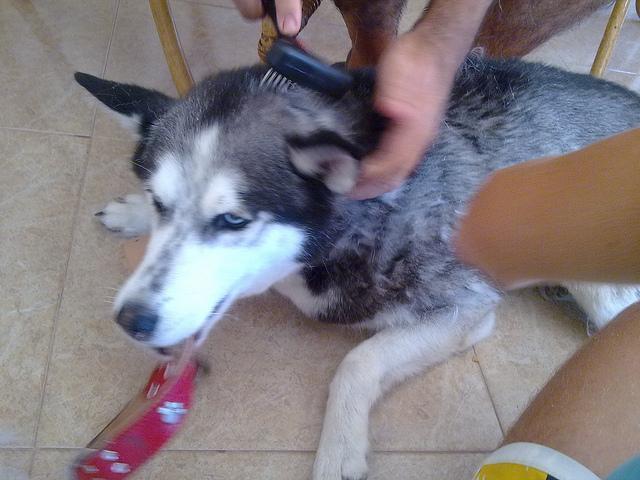How many people are visible?
Give a very brief answer. 2. 